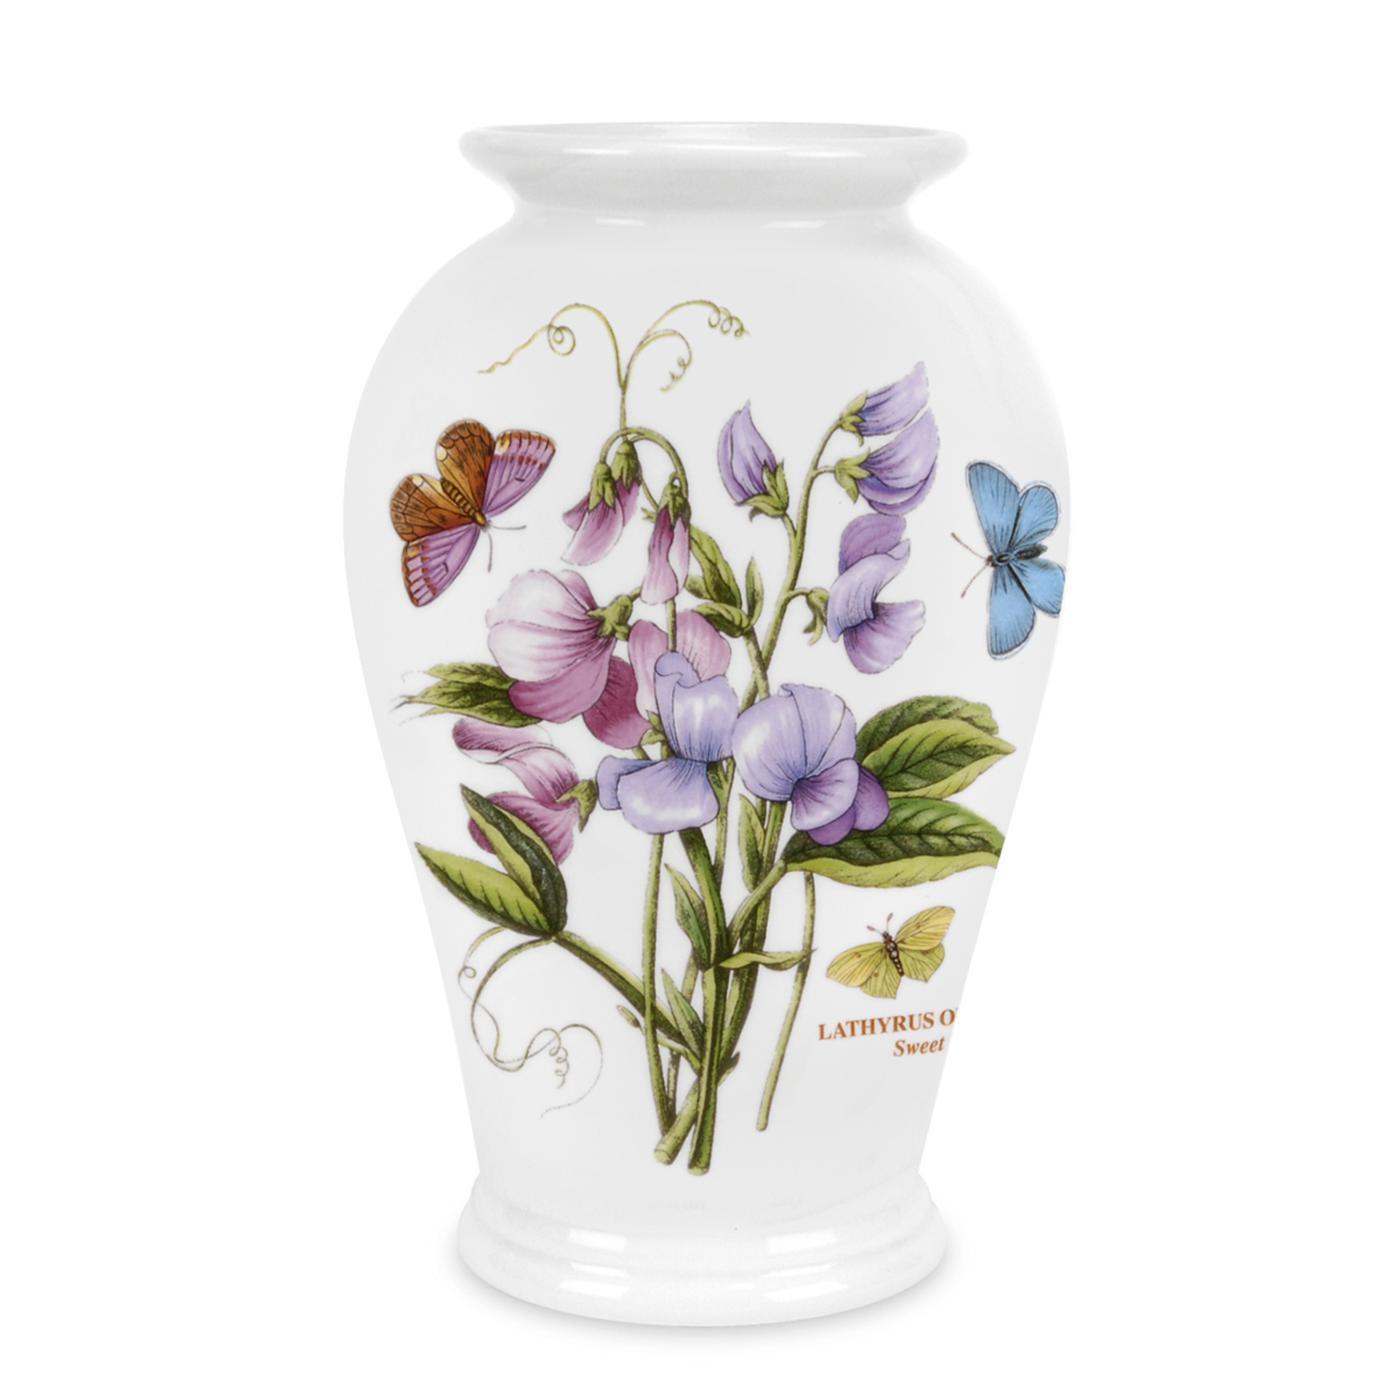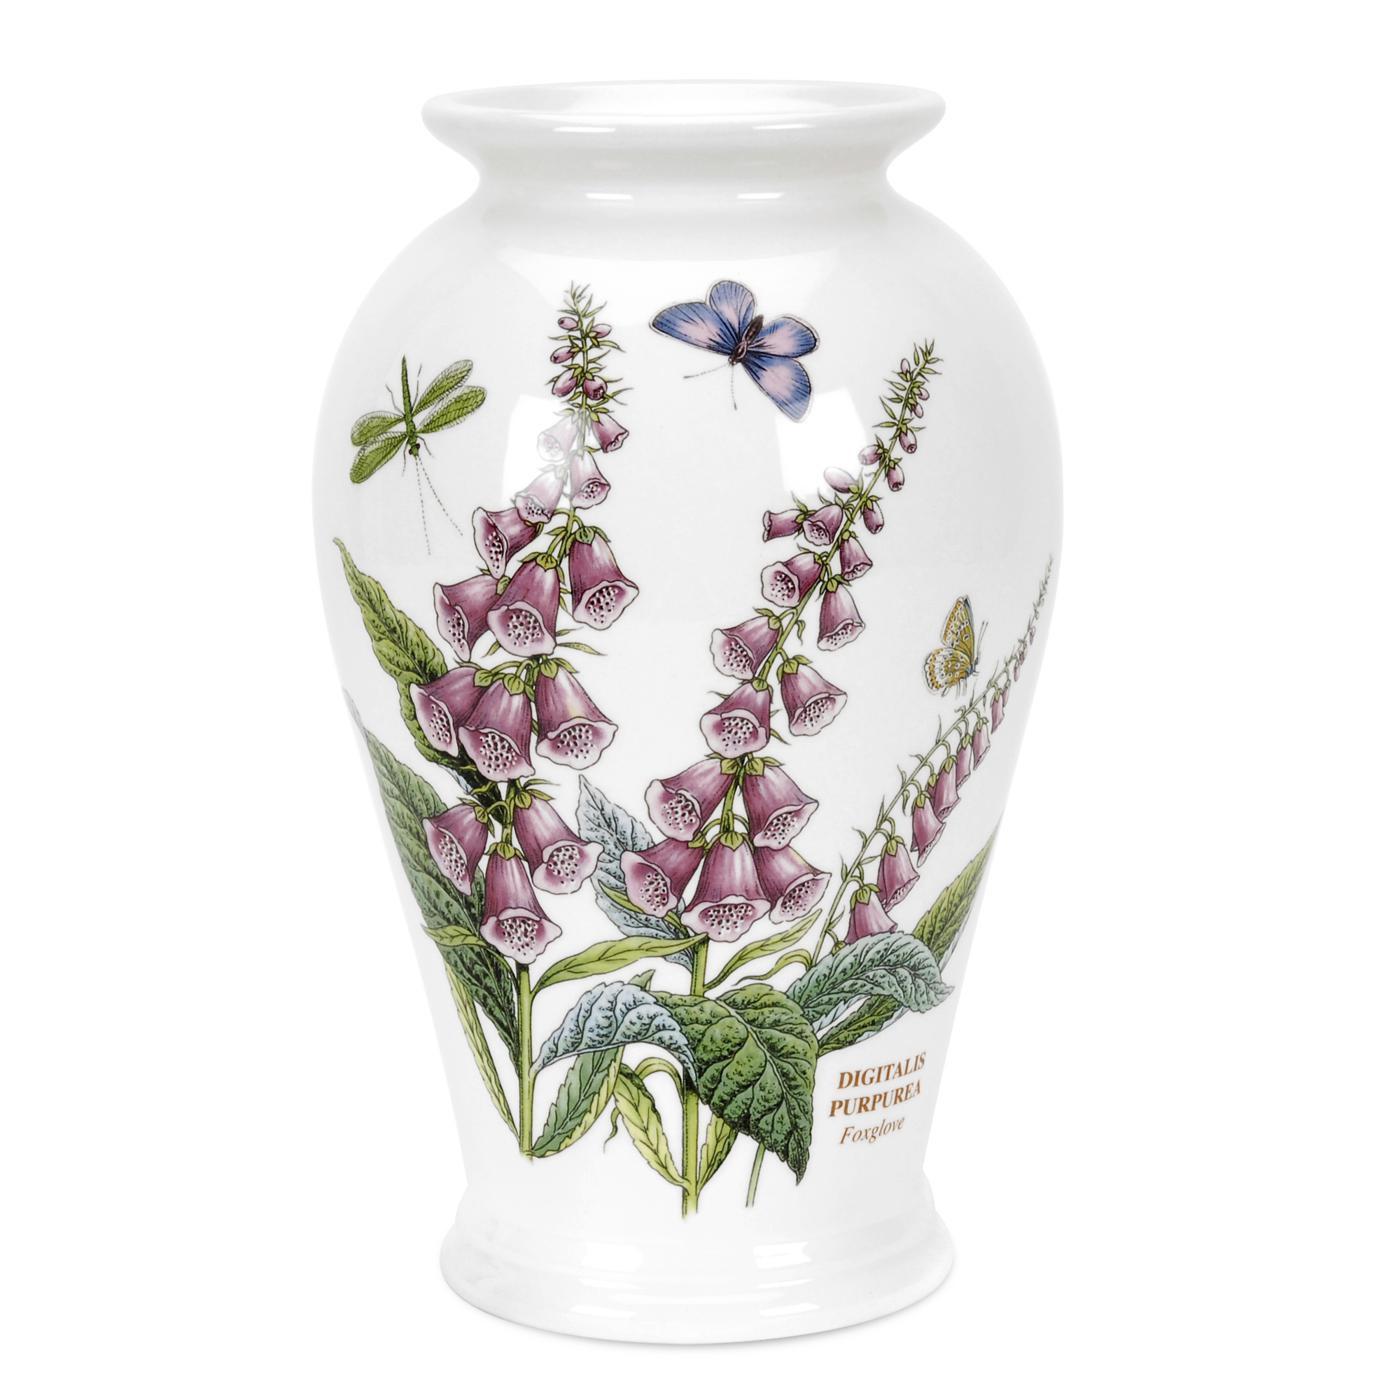The first image is the image on the left, the second image is the image on the right. Considering the images on both sides, is "One of the two vases is decorated with digitalis flowering plants and a purple butterfly, the other vase has a blue butterfly." valid? Answer yes or no. Yes. The first image is the image on the left, the second image is the image on the right. For the images shown, is this caption "Each image shows exactly one white vase, which does not hold any floral item." true? Answer yes or no. Yes. 